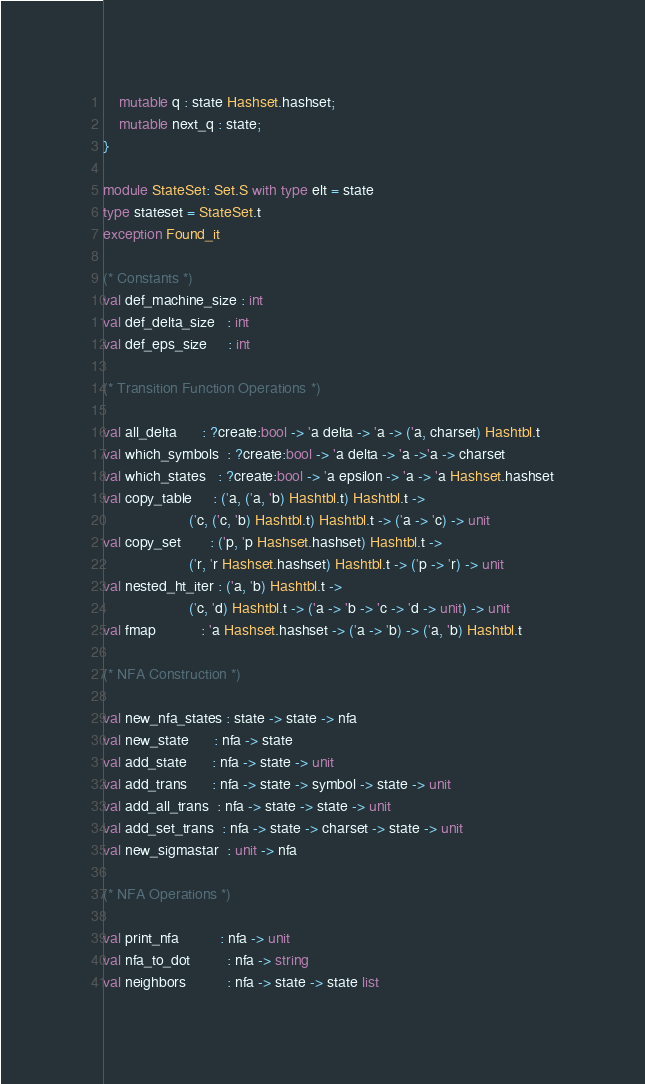Convert code to text. <code><loc_0><loc_0><loc_500><loc_500><_OCaml_>   	mutable q : state Hashset.hashset;
   	mutable next_q : state;
}

module StateSet: Set.S with type elt = state
type stateset = StateSet.t
exception Found_it

(* Constants *)
val def_machine_size : int
val def_delta_size   : int
val def_eps_size     : int

(* Transition Function Operations *)

val all_delta      : ?create:bool -> 'a delta -> 'a -> ('a, charset) Hashtbl.t
val which_symbols  : ?create:bool -> 'a delta -> 'a ->'a -> charset
val which_states   : ?create:bool -> 'a epsilon -> 'a -> 'a Hashset.hashset
val copy_table     : ('a, ('a, 'b) Hashtbl.t) Hashtbl.t ->
                     ('c, ('c, 'b) Hashtbl.t) Hashtbl.t -> ('a -> 'c) -> unit
val copy_set       : ('p, 'p Hashset.hashset) Hashtbl.t ->
                     ('r, 'r Hashset.hashset) Hashtbl.t -> ('p -> 'r) -> unit
val nested_ht_iter : ('a, 'b) Hashtbl.t ->
                     ('c, 'd) Hashtbl.t -> ('a -> 'b -> 'c -> 'd -> unit) -> unit
val fmap           : 'a Hashset.hashset -> ('a -> 'b) -> ('a, 'b) Hashtbl.t

(* NFA Construction *)

val new_nfa_states : state -> state -> nfa
val new_state      : nfa -> state
val add_state      : nfa -> state -> unit
val add_trans      : nfa -> state -> symbol -> state -> unit
val add_all_trans  : nfa -> state -> state -> unit
val add_set_trans  : nfa -> state -> charset -> state -> unit
val new_sigmastar  : unit -> nfa

(* NFA Operations *)

val print_nfa          : nfa -> unit
val nfa_to_dot         : nfa -> string
val neighbors          : nfa -> state -> state list</code> 